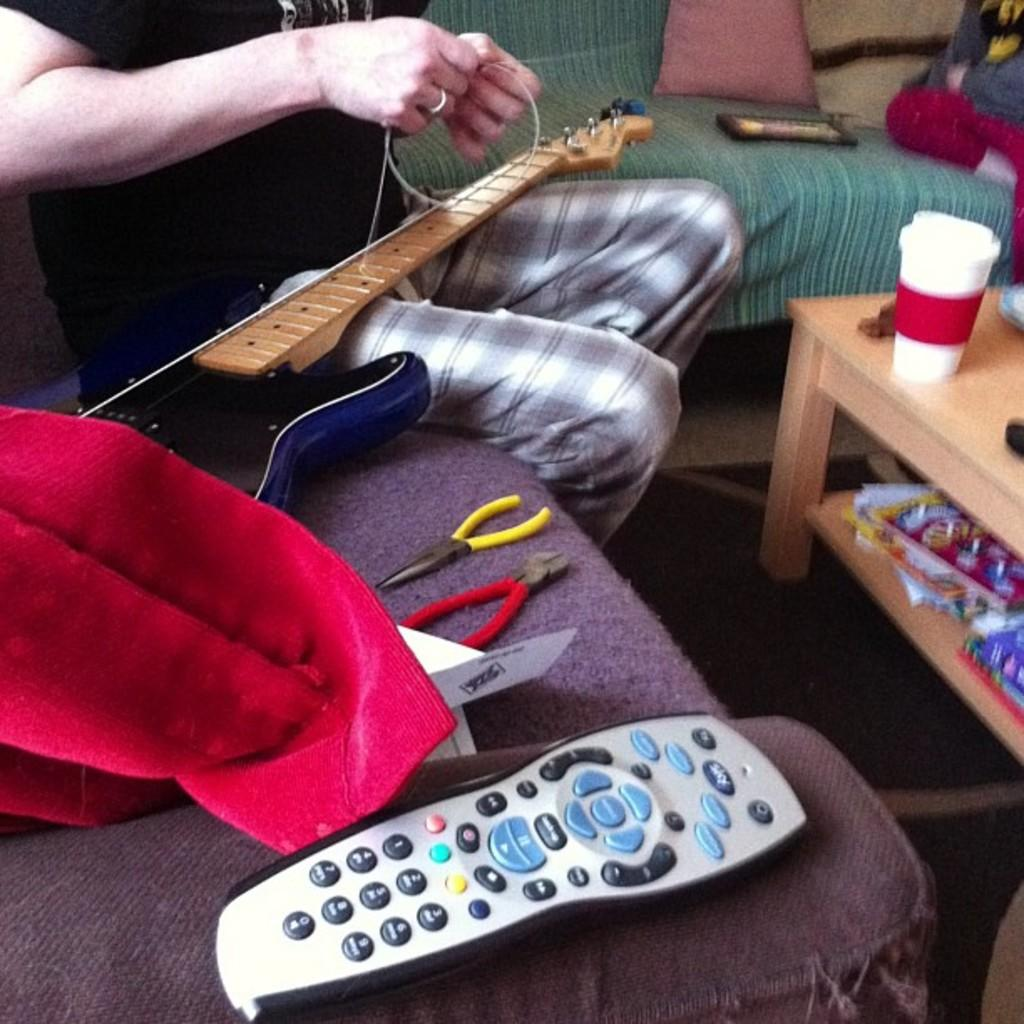<image>
Offer a succinct explanation of the picture presented. A person sitting on a couch stringing a guitar with a tv remote next to them that has the numbers 1 through 9 on it. 